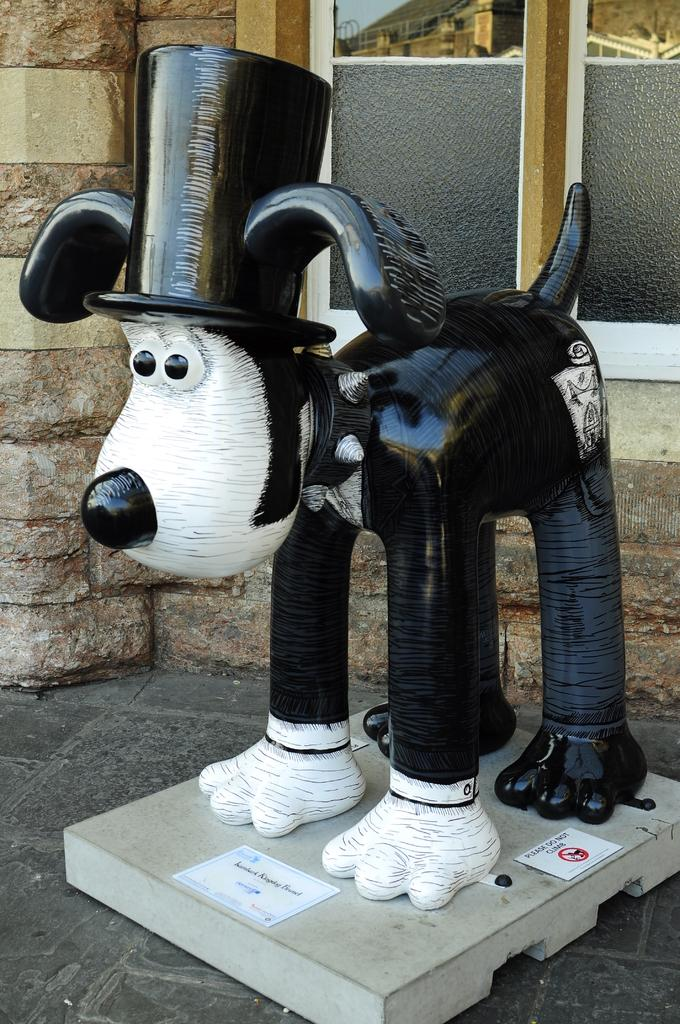What is the main subject in the front of the image? There is a statue in the front of the image. What is located at the bottom of the statue? There are two papers at the bottom of the statue. What can be seen in the background of the image? There is a wall and a window in the background of the image. What type of tin can be seen floating in the ocean in the image? There is no tin or ocean present in the image; it features a statue with papers at the bottom and a wall and window in the background. 